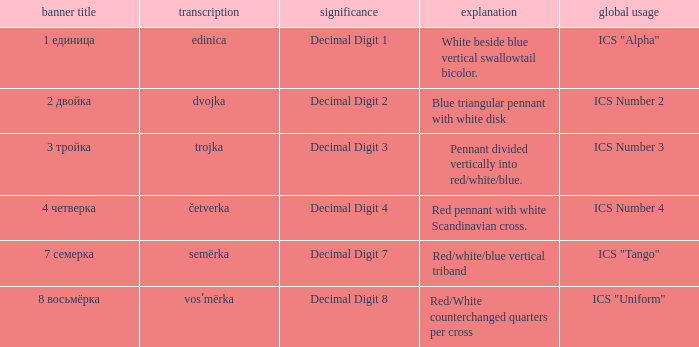What are the meanings of the flag whose name transliterates to semërka? Decimal Digit 7. 